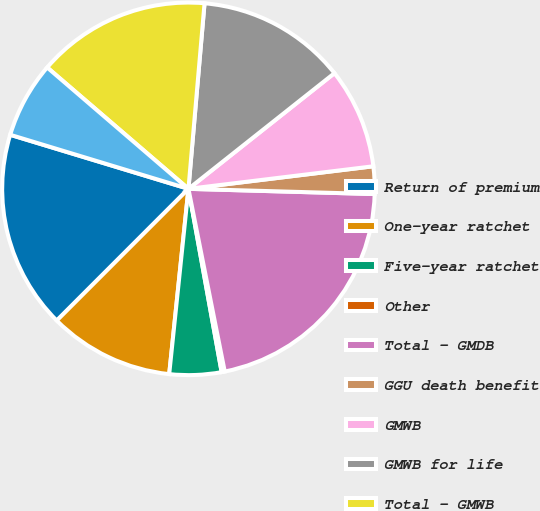Convert chart to OTSL. <chart><loc_0><loc_0><loc_500><loc_500><pie_chart><fcel>Return of premium<fcel>One-year ratchet<fcel>Five-year ratchet<fcel>Other<fcel>Total - GMDB<fcel>GGU death benefit<fcel>GMWB<fcel>GMWB for life<fcel>Total - GMWB<fcel>GMAB<nl><fcel>17.19%<fcel>10.85%<fcel>4.5%<fcel>0.27%<fcel>21.43%<fcel>2.38%<fcel>8.73%<fcel>12.96%<fcel>15.08%<fcel>6.61%<nl></chart> 